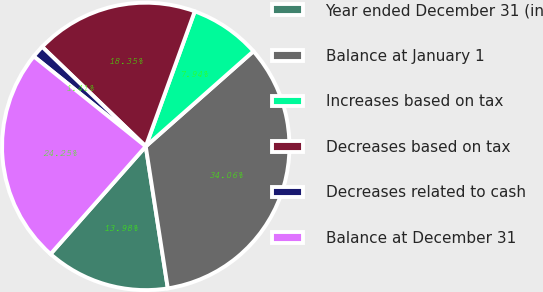Convert chart. <chart><loc_0><loc_0><loc_500><loc_500><pie_chart><fcel>Year ended December 31 (in<fcel>Balance at January 1<fcel>Increases based on tax<fcel>Decreases based on tax<fcel>Decreases related to cash<fcel>Balance at December 31<nl><fcel>13.98%<fcel>34.06%<fcel>7.94%<fcel>18.35%<fcel>1.41%<fcel>24.25%<nl></chart> 